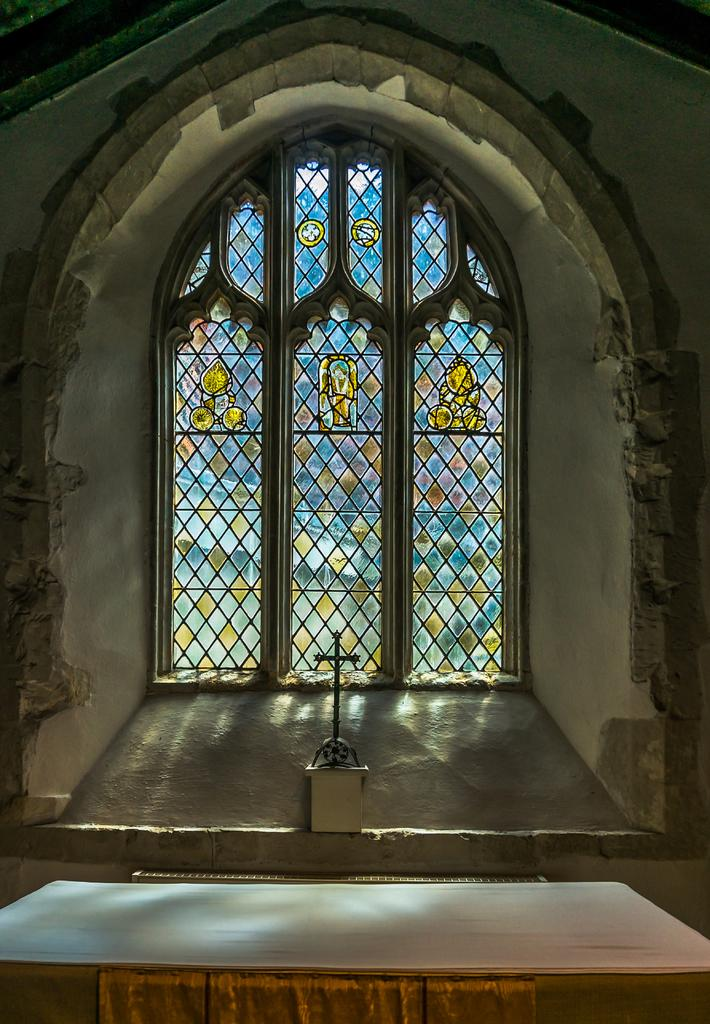What is located in the center of the image? There is a window in the center of the image. What religious symbol can be seen in the image? There is a cross in the image. What type of structure is visible in the image? There is a wall in the image. What is at the bottom of the image? There is a board at the bottom of the image. Where is the dock located in the image? There is no dock present in the image. What type of vegetable is growing on the wall in the image? There is no vegetable, specifically lettuce, present in the image. 